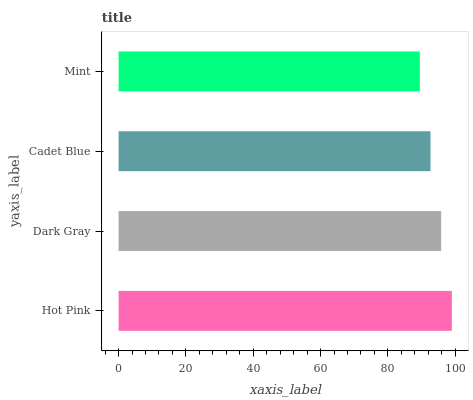Is Mint the minimum?
Answer yes or no. Yes. Is Hot Pink the maximum?
Answer yes or no. Yes. Is Dark Gray the minimum?
Answer yes or no. No. Is Dark Gray the maximum?
Answer yes or no. No. Is Hot Pink greater than Dark Gray?
Answer yes or no. Yes. Is Dark Gray less than Hot Pink?
Answer yes or no. Yes. Is Dark Gray greater than Hot Pink?
Answer yes or no. No. Is Hot Pink less than Dark Gray?
Answer yes or no. No. Is Dark Gray the high median?
Answer yes or no. Yes. Is Cadet Blue the low median?
Answer yes or no. Yes. Is Cadet Blue the high median?
Answer yes or no. No. Is Hot Pink the low median?
Answer yes or no. No. 